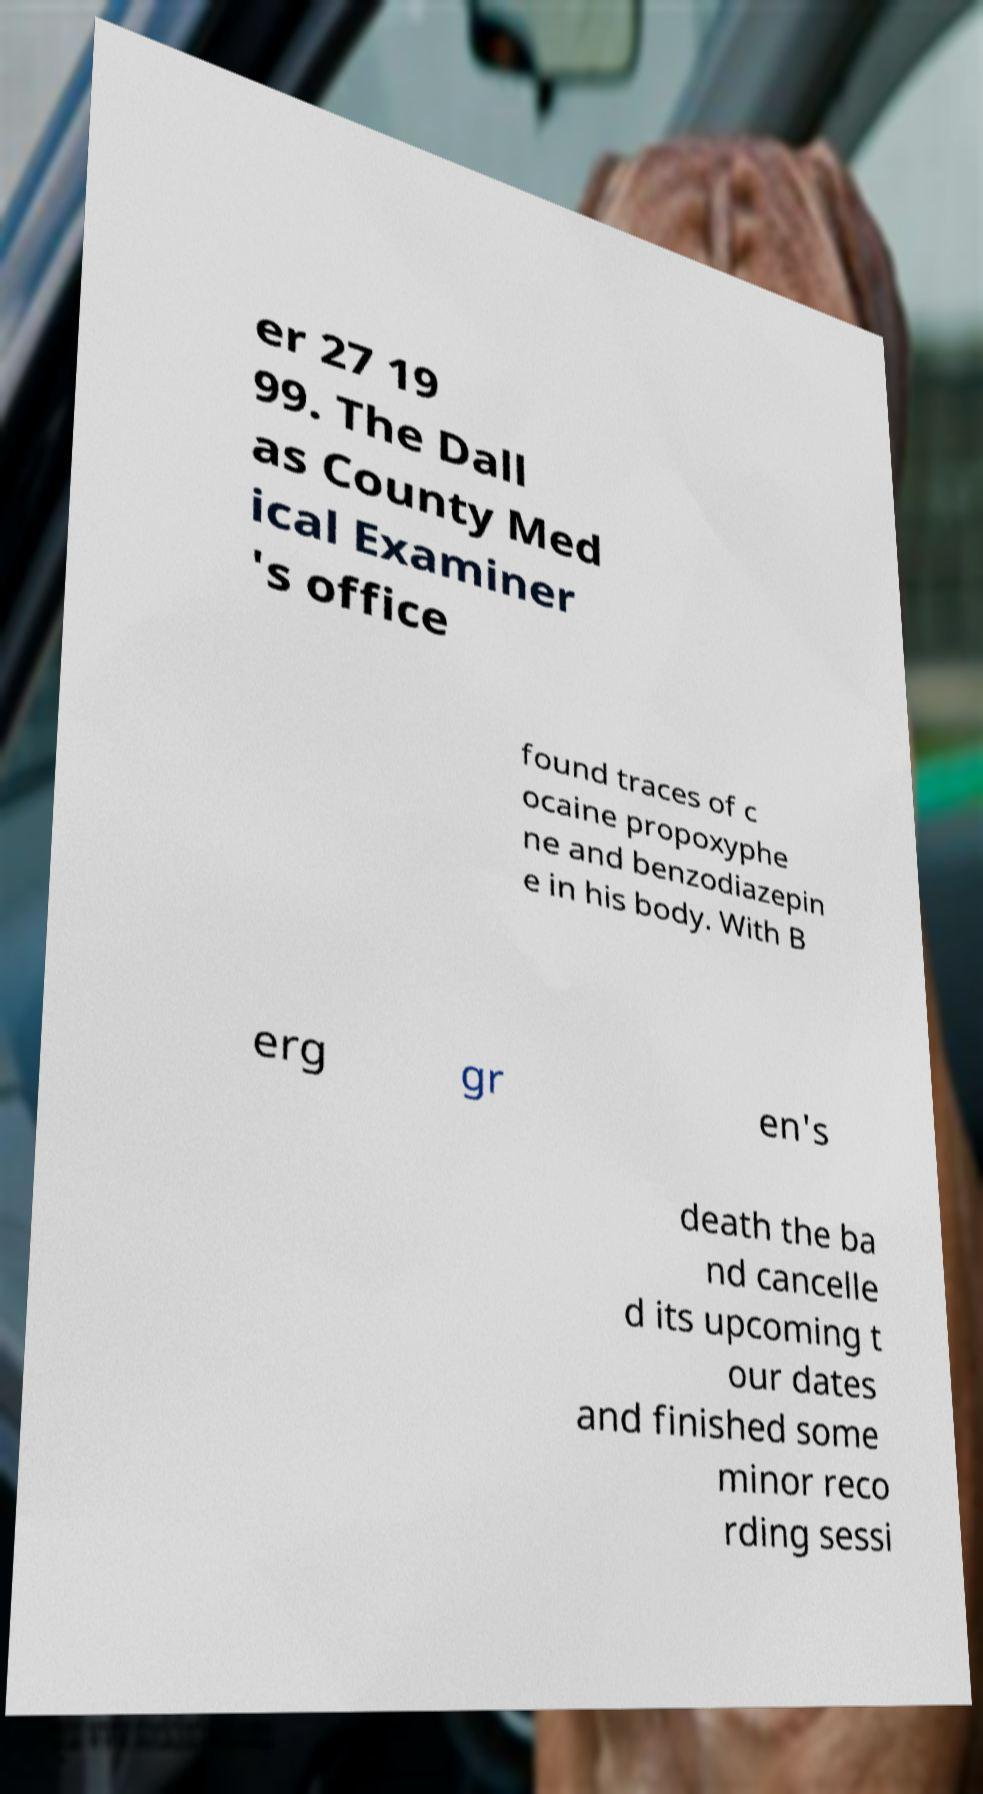Please read and relay the text visible in this image. What does it say? er 27 19 99. The Dall as County Med ical Examiner 's office found traces of c ocaine propoxyphe ne and benzodiazepin e in his body. With B erg gr en's death the ba nd cancelle d its upcoming t our dates and finished some minor reco rding sessi 